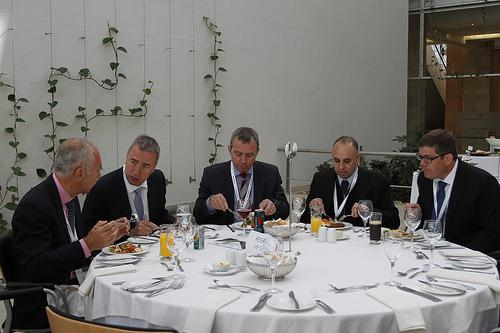Question: who is eating at the table?
Choices:
A. Men.
B. A family.
C. Children.
D. Women.
Answer with the letter. Answer: A Question: what color are the suits?
Choices:
A. Black.
B. Gray.
C. Blue.
D. Beige.
Answer with the letter. Answer: A Question: where was this picture taken?
Choices:
A. A store.
B. A pizza shop.
C. A bakery.
D. In a restaurant.
Answer with the letter. Answer: D Question: why are the men eating?
Choices:
A. For nutrition.
B. They are hungry.
C. It is lunch time.
D. It is dinner time.
Answer with the letter. Answer: B Question: when was this picture taken?
Choices:
A. At a party.
B. During a meal.
C. During a game.
D. The morning.
Answer with the letter. Answer: B Question: how many men are at the table?
Choices:
A. Five.
B. Four.
C. Six.
D. Seven.
Answer with the letter. Answer: A 